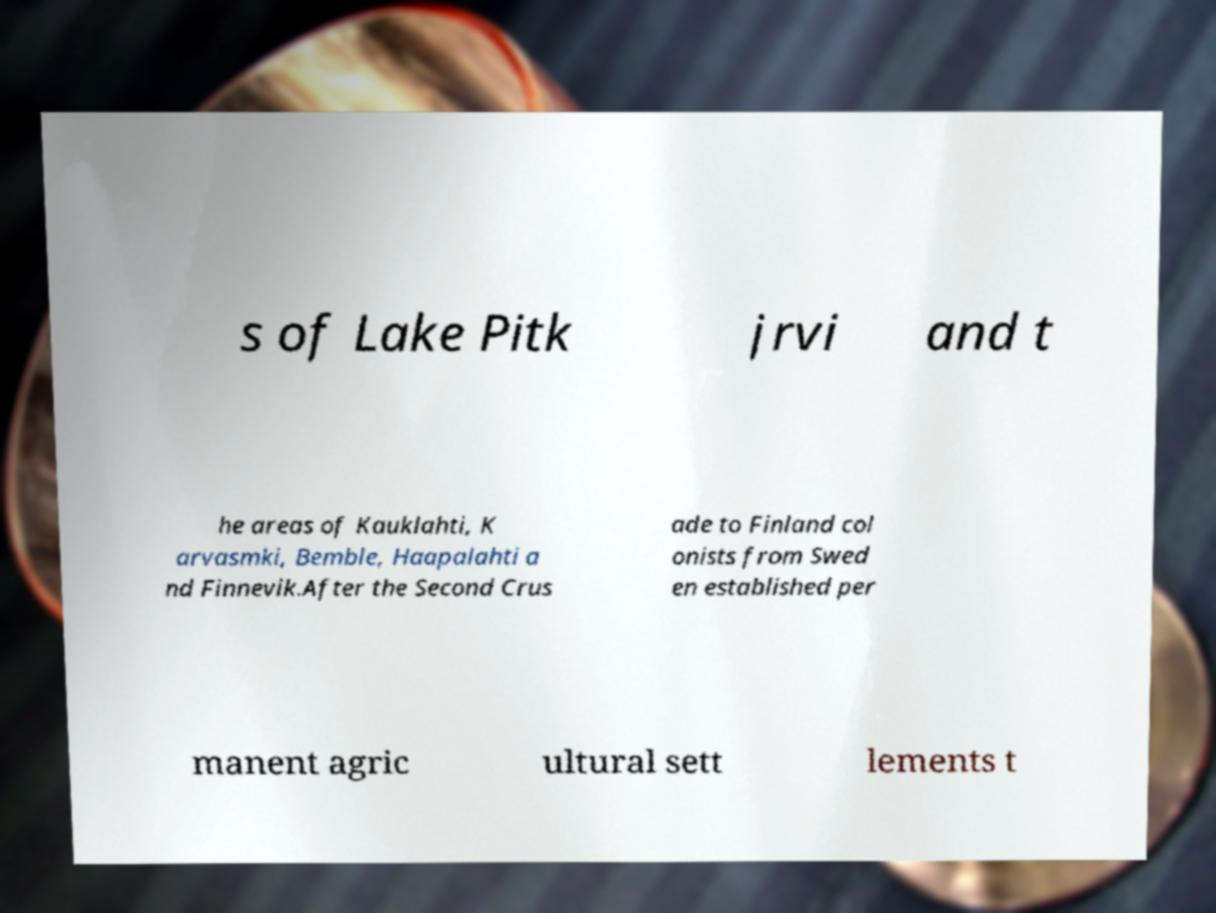I need the written content from this picture converted into text. Can you do that? s of Lake Pitk jrvi and t he areas of Kauklahti, K arvasmki, Bemble, Haapalahti a nd Finnevik.After the Second Crus ade to Finland col onists from Swed en established per manent agric ultural sett lements t 